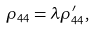<formula> <loc_0><loc_0><loc_500><loc_500>\rho _ { 4 4 } = \lambda \rho _ { 4 4 } ^ { \prime } ,</formula> 